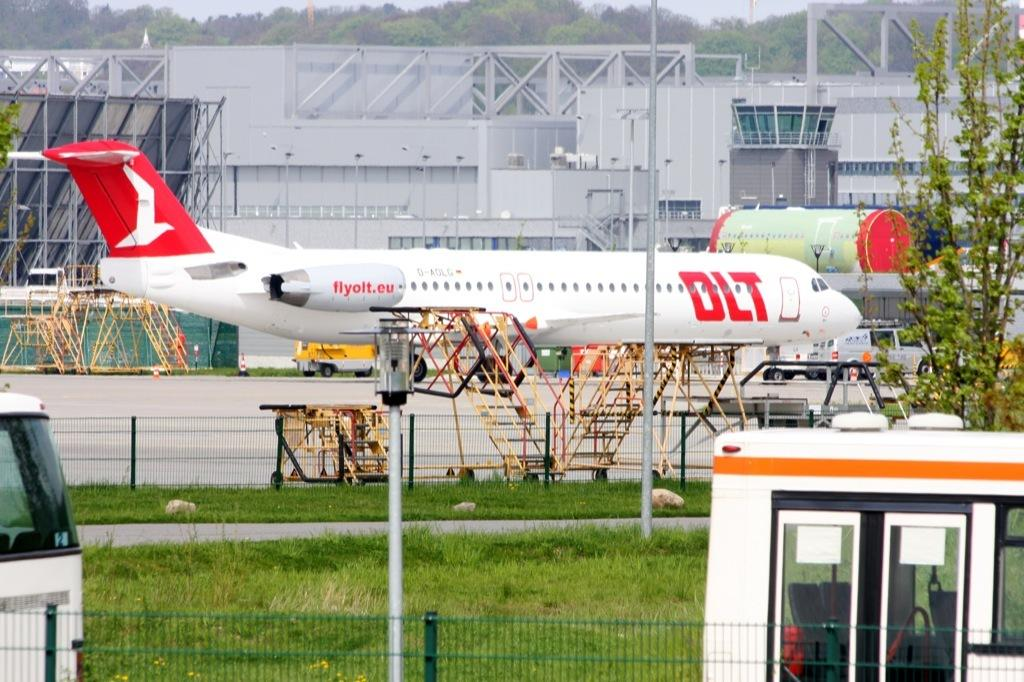<image>
Render a clear and concise summary of the photo. A white and red airplane displaying the website flyolt.eu 